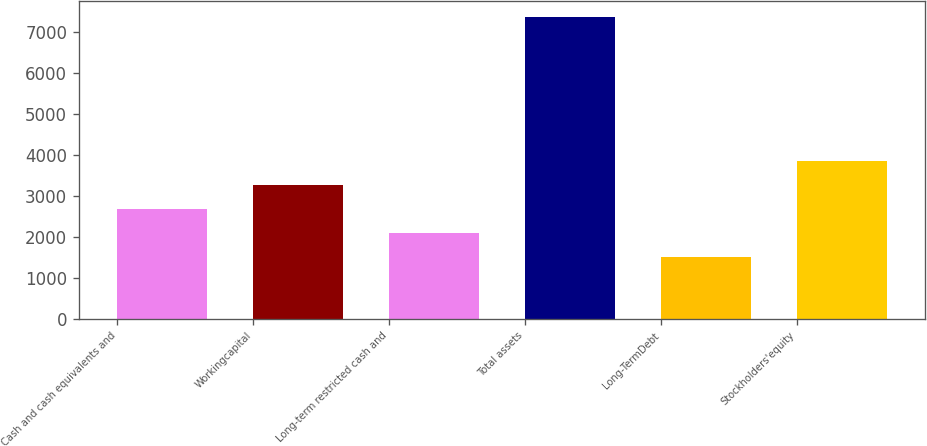<chart> <loc_0><loc_0><loc_500><loc_500><bar_chart><fcel>Cash and cash equivalents and<fcel>Workingcapital<fcel>Long-term restricted cash and<fcel>Total assets<fcel>Long-TermDebt<fcel>Stockholders'equity<nl><fcel>2673.8<fcel>3260.7<fcel>2086.9<fcel>7369<fcel>1500<fcel>3847.6<nl></chart> 